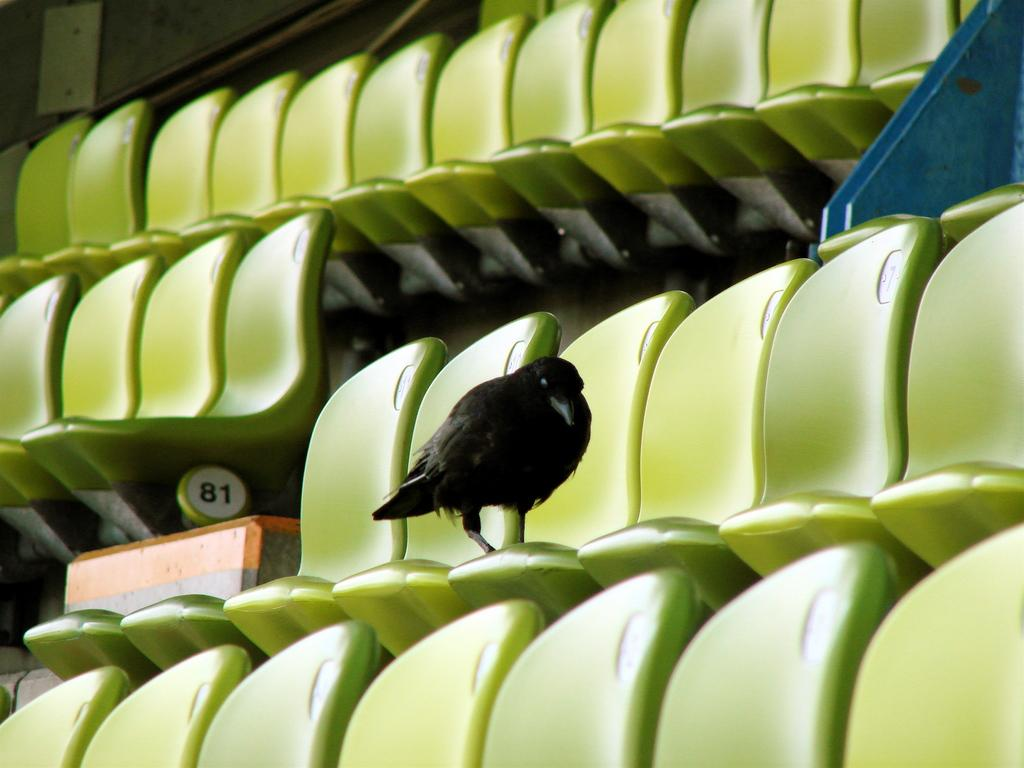What is the main subject in the foreground of the image? There is a crow on a chair in the foreground of the image. What color are the chairs in the image? The chairs in the image are green. What can be seen on the left side of the image? There are digits on the left side of the image. What color is the object on the right side of the image? There is a blue color object on the right side of the image. What word is being processed by the crow in the image? There is no indication in the image that the crow is processing any words. 